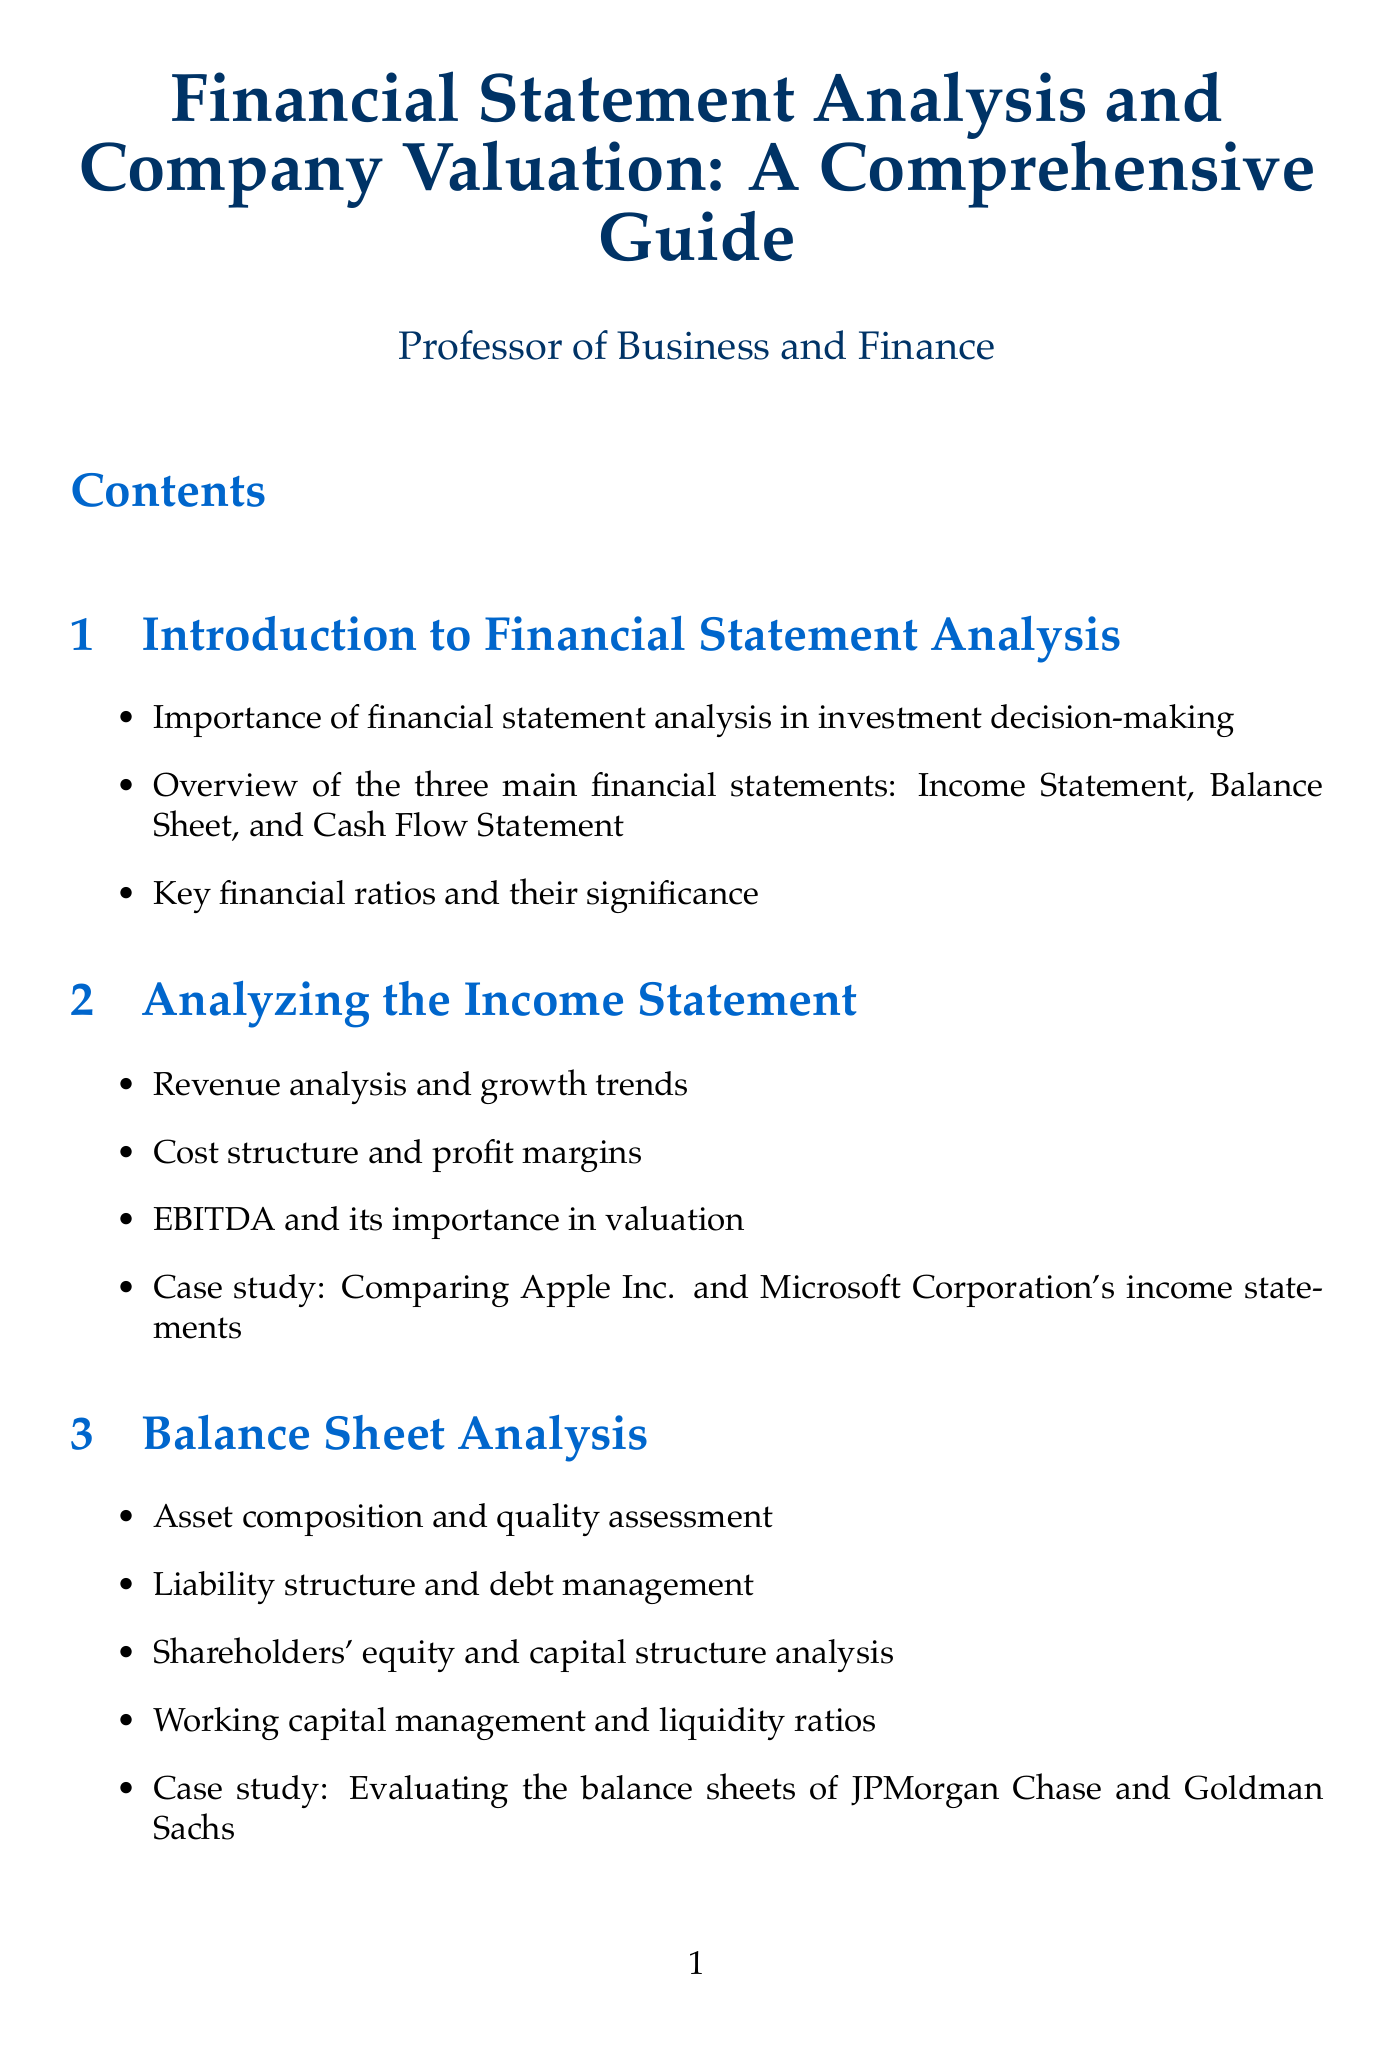what are the three main financial statements? The document outlines the three main financial statements which are highlighted in the introduction section.
Answer: Income Statement, Balance Sheet, and Cash Flow Statement what is the focus of the case study in the Income Statement section? The case study in the Income Statement section compares two prominent companies to illustrate concepts discussed.
Answer: Comparing Apple Inc. and Microsoft Corporation's income statements which ratios are included under Profitability ratios? The document lists specific ratios in the Financial Ratios and Metrics section, focusing on profitability.
Answer: ROE, ROA, and ROIC what are key metrics for technology companies according to the Industry-Specific Considerations section? This section identifies specific metrics that are crucial in analyzing technology firms.
Answer: Monthly Active Users, Customer Acquisition Cost what valuation methods are discussed in the Valuation Methodologies section? The document lists various methodologies for conducting valuation, emphasizing several approaches.
Answer: Discounted Cash Flow (DCF) analysis, Comparable company analysis, Precedent transactions analysis, Asset-based valuation how many appendices are included in the document? The structure of the document reveals specific appendices that provide additional resources and insights.
Answer: Three what is a key aspect of the Practical Application and Report Writing section? This section emphasizes how to effectively communicate findings and integrate financial analysis into reports.
Answer: Structuring a comprehensive financial analysis report which financial databases are recommended in the Resources section? The document recommends several databases for financial information useful in analysis and research.
Answer: Bloomberg Terminal, S&P Capital IQ, FactSet, Morningstar 